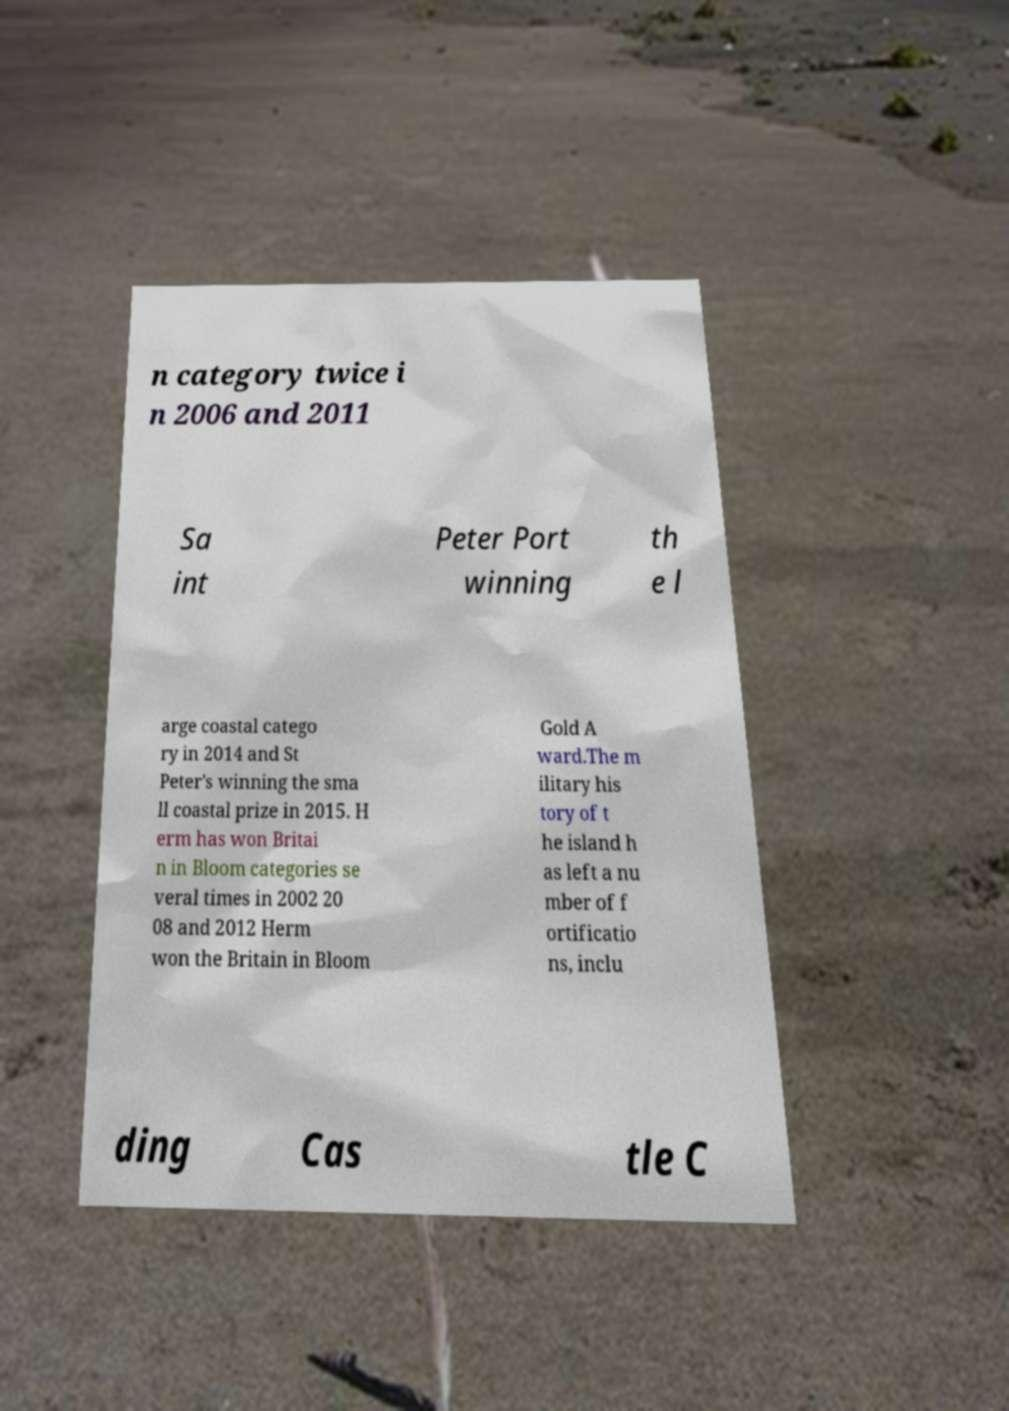Please read and relay the text visible in this image. What does it say? n category twice i n 2006 and 2011 Sa int Peter Port winning th e l arge coastal catego ry in 2014 and St Peter's winning the sma ll coastal prize in 2015. H erm has won Britai n in Bloom categories se veral times in 2002 20 08 and 2012 Herm won the Britain in Bloom Gold A ward.The m ilitary his tory of t he island h as left a nu mber of f ortificatio ns, inclu ding Cas tle C 